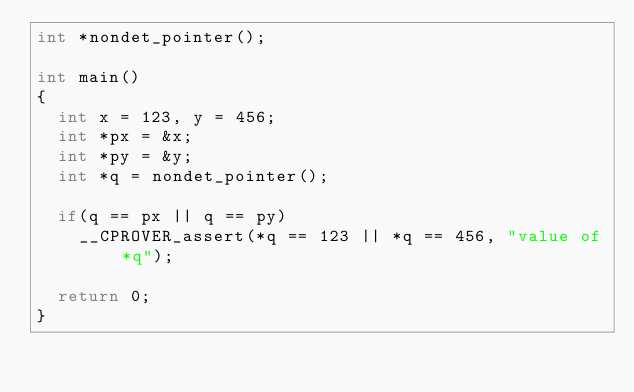Convert code to text. <code><loc_0><loc_0><loc_500><loc_500><_C_>int *nondet_pointer();

int main()
{
  int x = 123, y = 456;
  int *px = &x;
  int *py = &y;
  int *q = nondet_pointer();

  if(q == px || q == py)
    __CPROVER_assert(*q == 123 || *q == 456, "value of *q");

  return 0;
}
</code> 